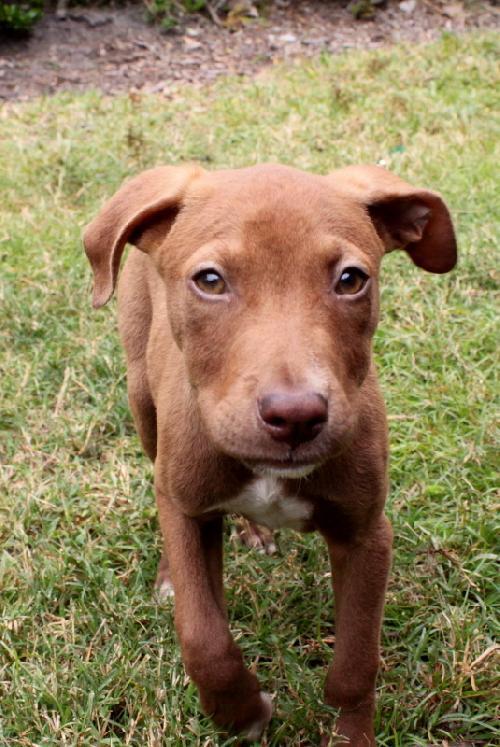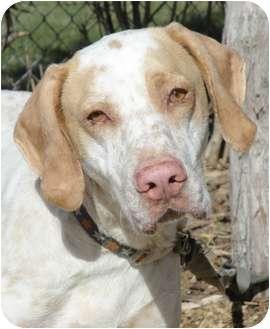The first image is the image on the left, the second image is the image on the right. For the images displayed, is the sentence "Each image contains one dog, and the righthand dog has its pink tongue extended past its teeth." factually correct? Answer yes or no. No. The first image is the image on the left, the second image is the image on the right. Given the left and right images, does the statement "At least one dog is on a leash." hold true? Answer yes or no. Yes. 